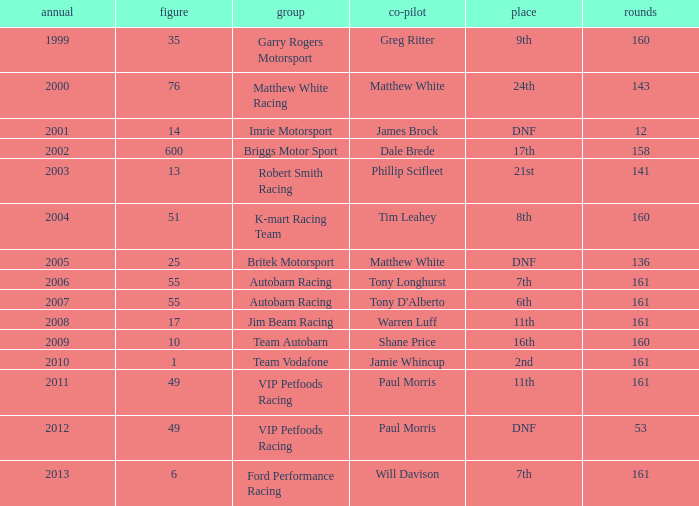Would you mind parsing the complete table? {'header': ['annual', 'figure', 'group', 'co-pilot', 'place', 'rounds'], 'rows': [['1999', '35', 'Garry Rogers Motorsport', 'Greg Ritter', '9th', '160'], ['2000', '76', 'Matthew White Racing', 'Matthew White', '24th', '143'], ['2001', '14', 'Imrie Motorsport', 'James Brock', 'DNF', '12'], ['2002', '600', 'Briggs Motor Sport', 'Dale Brede', '17th', '158'], ['2003', '13', 'Robert Smith Racing', 'Phillip Scifleet', '21st', '141'], ['2004', '51', 'K-mart Racing Team', 'Tim Leahey', '8th', '160'], ['2005', '25', 'Britek Motorsport', 'Matthew White', 'DNF', '136'], ['2006', '55', 'Autobarn Racing', 'Tony Longhurst', '7th', '161'], ['2007', '55', 'Autobarn Racing', "Tony D'Alberto", '6th', '161'], ['2008', '17', 'Jim Beam Racing', 'Warren Luff', '11th', '161'], ['2009', '10', 'Team Autobarn', 'Shane Price', '16th', '160'], ['2010', '1', 'Team Vodafone', 'Jamie Whincup', '2nd', '161'], ['2011', '49', 'VIP Petfoods Racing', 'Paul Morris', '11th', '161'], ['2012', '49', 'VIP Petfoods Racing', 'Paul Morris', 'DNF', '53'], ['2013', '6', 'Ford Performance Racing', 'Will Davison', '7th', '161']]} Who was the co-driver for the team with more than 160 laps and the number 6 after 2010? Will Davison. 